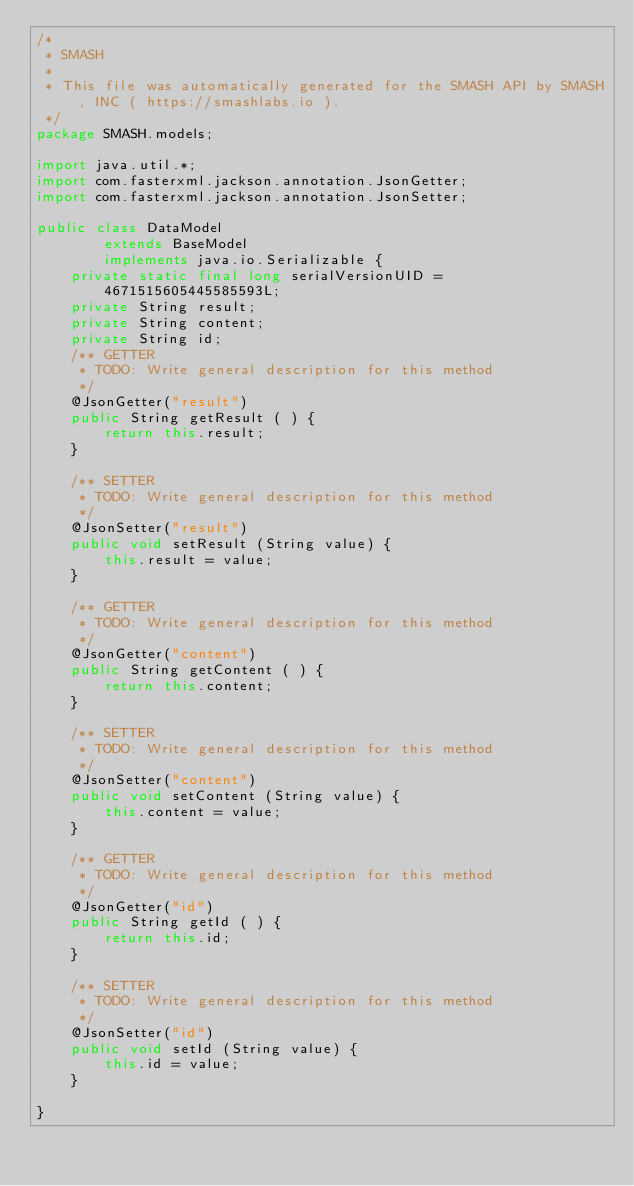<code> <loc_0><loc_0><loc_500><loc_500><_Java_>/*
 * SMASH
 *
 * This file was automatically generated for the SMASH API by SMASH, INC ( https://smashlabs.io ).
 */
package SMASH.models;

import java.util.*;
import com.fasterxml.jackson.annotation.JsonGetter;
import com.fasterxml.jackson.annotation.JsonSetter;

public class DataModel 
        extends BaseModel
        implements java.io.Serializable {
    private static final long serialVersionUID = 4671515605445585593L;
    private String result;
    private String content;
    private String id;
    /** GETTER
     * TODO: Write general description for this method
     */
    @JsonGetter("result")
    public String getResult ( ) { 
        return this.result;
    }
    
    /** SETTER
     * TODO: Write general description for this method
     */
    @JsonSetter("result")
    public void setResult (String value) { 
        this.result = value;
    }
 
    /** GETTER
     * TODO: Write general description for this method
     */
    @JsonGetter("content")
    public String getContent ( ) { 
        return this.content;
    }
    
    /** SETTER
     * TODO: Write general description for this method
     */
    @JsonSetter("content")
    public void setContent (String value) { 
        this.content = value;
    }
 
    /** GETTER
     * TODO: Write general description for this method
     */
    @JsonGetter("id")
    public String getId ( ) { 
        return this.id;
    }
    
    /** SETTER
     * TODO: Write general description for this method
     */
    @JsonSetter("id")
    public void setId (String value) { 
        this.id = value;
    }
 
}
 </code> 